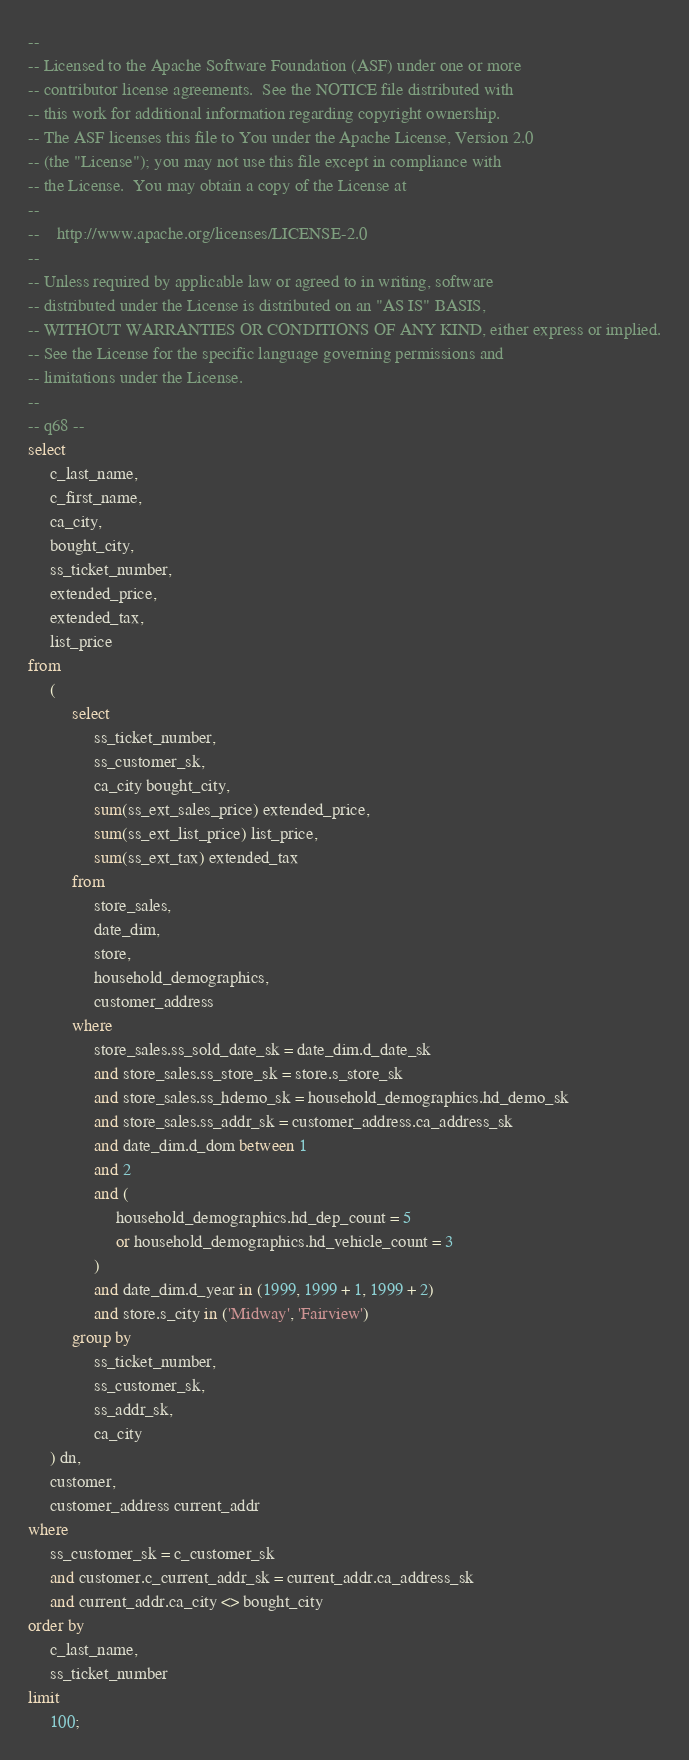<code> <loc_0><loc_0><loc_500><loc_500><_SQL_>--
-- Licensed to the Apache Software Foundation (ASF) under one or more
-- contributor license agreements.  See the NOTICE file distributed with
-- this work for additional information regarding copyright ownership.
-- The ASF licenses this file to You under the Apache License, Version 2.0
-- (the "License"); you may not use this file except in compliance with
-- the License.  You may obtain a copy of the License at
--
--    http://www.apache.org/licenses/LICENSE-2.0
--
-- Unless required by applicable law or agreed to in writing, software
-- distributed under the License is distributed on an "AS IS" BASIS,
-- WITHOUT WARRANTIES OR CONDITIONS OF ANY KIND, either express or implied.
-- See the License for the specific language governing permissions and
-- limitations under the License.
--
-- q68 --
select
     c_last_name,
     c_first_name,
     ca_city,
     bought_city,
     ss_ticket_number,
     extended_price,
     extended_tax,
     list_price
from
     (
          select
               ss_ticket_number,
               ss_customer_sk,
               ca_city bought_city,
               sum(ss_ext_sales_price) extended_price,
               sum(ss_ext_list_price) list_price,
               sum(ss_ext_tax) extended_tax
          from
               store_sales,
               date_dim,
               store,
               household_demographics,
               customer_address
          where
               store_sales.ss_sold_date_sk = date_dim.d_date_sk
               and store_sales.ss_store_sk = store.s_store_sk
               and store_sales.ss_hdemo_sk = household_demographics.hd_demo_sk
               and store_sales.ss_addr_sk = customer_address.ca_address_sk
               and date_dim.d_dom between 1
               and 2
               and (
                    household_demographics.hd_dep_count = 5
                    or household_demographics.hd_vehicle_count = 3
               )
               and date_dim.d_year in (1999, 1999 + 1, 1999 + 2)
               and store.s_city in ('Midway', 'Fairview')
          group by
               ss_ticket_number,
               ss_customer_sk,
               ss_addr_sk,
               ca_city
     ) dn,
     customer,
     customer_address current_addr
where
     ss_customer_sk = c_customer_sk
     and customer.c_current_addr_sk = current_addr.ca_address_sk
     and current_addr.ca_city <> bought_city
order by
     c_last_name,
     ss_ticket_number
limit
     100;
</code> 